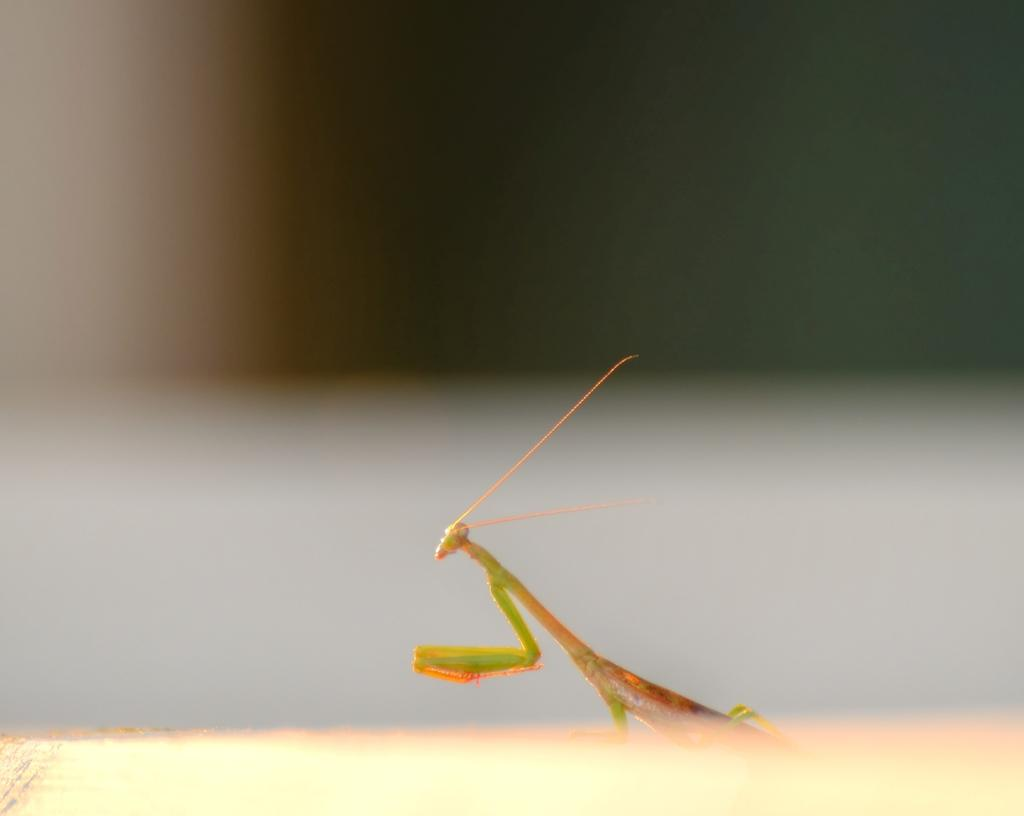What is the main subject of the image? There is a grasshopper in the image. Where is the grasshopper located in the image? The grasshopper is in the center of the image. What color is the grasshopper? The grasshopper is green in color. What type of agreement is being signed by the grasshopper in the image? There is no agreement or signing activity depicted in the image; it features a grasshopper that is green in color and located in the center of the image. 